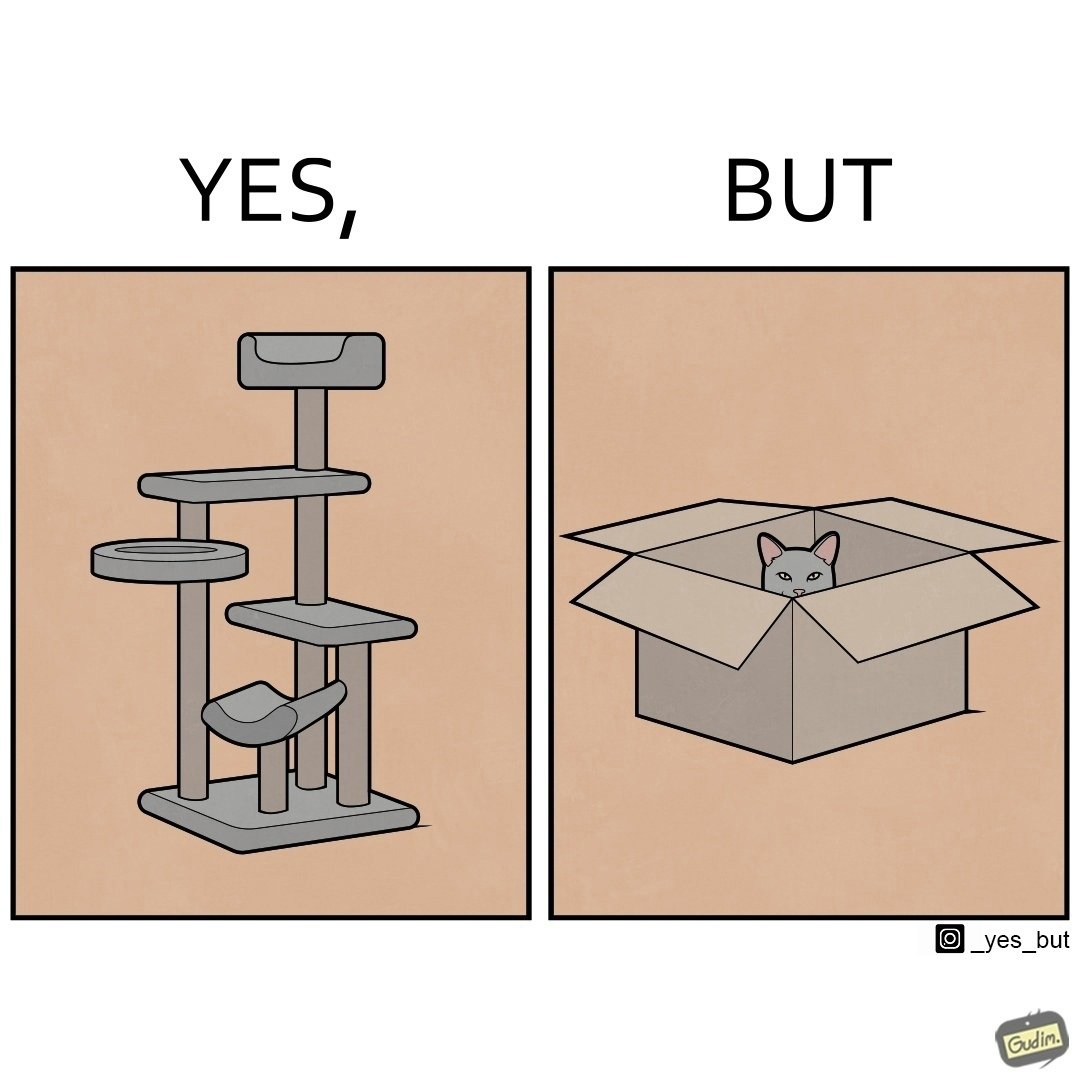Does this image contain satire or humor? Yes, this image is satirical. 